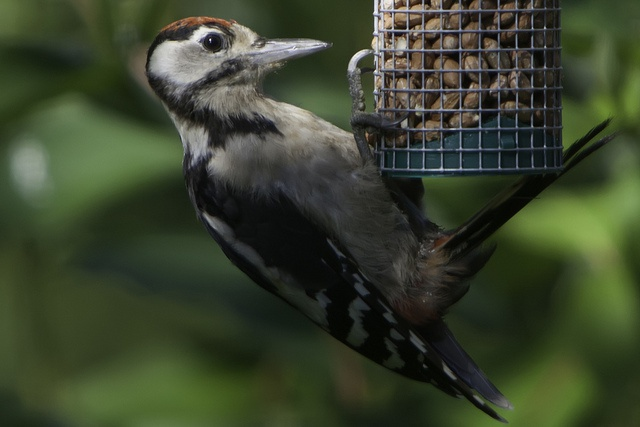Describe the objects in this image and their specific colors. I can see a bird in olive, black, gray, darkgray, and darkgreen tones in this image. 